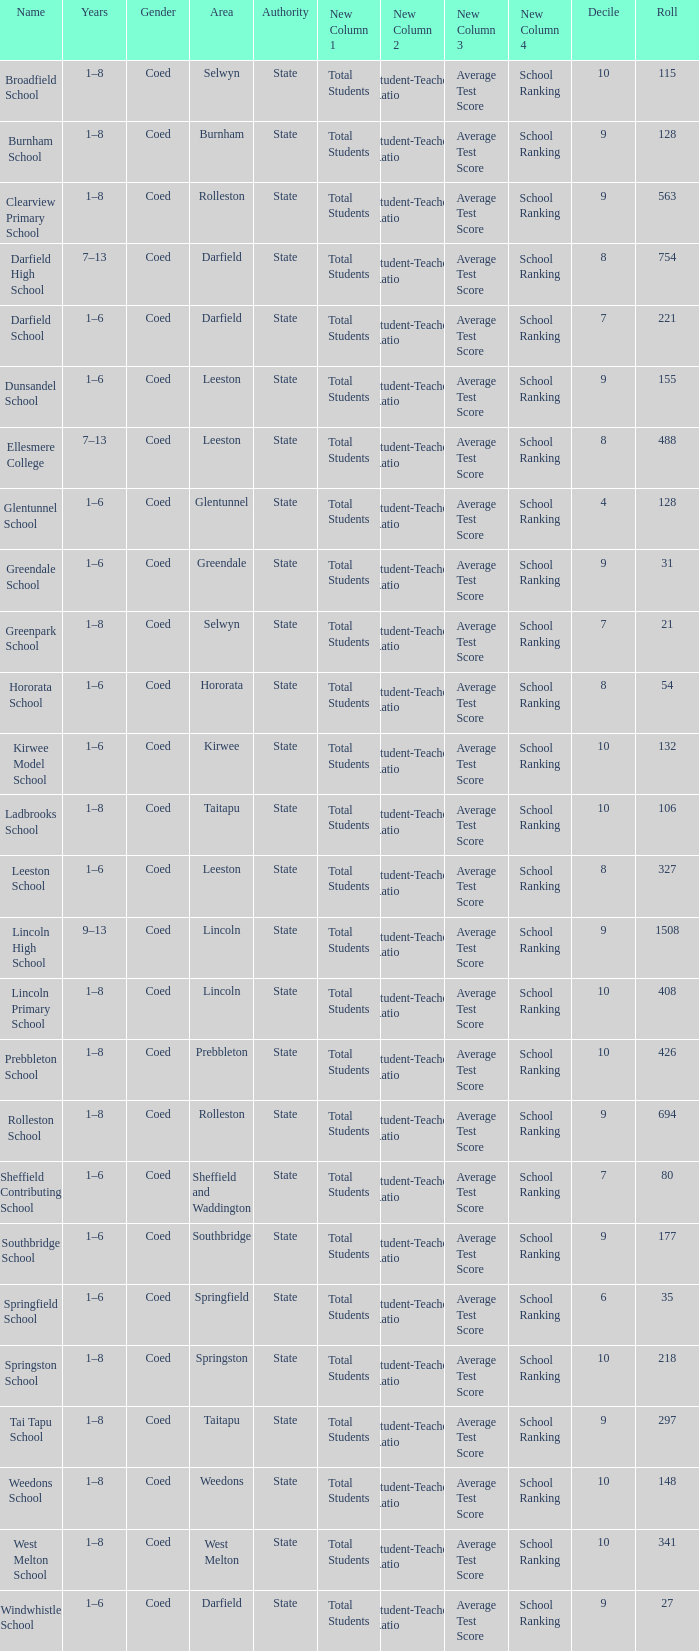Which name has a Roll larger than 297, and Years of 7–13? Darfield High School, Ellesmere College. Parse the table in full. {'header': ['Name', 'Years', 'Gender', 'Area', 'Authority', 'New Column 1', 'New Column 2', 'New Column 3', 'New Column 4', 'Decile', 'Roll'], 'rows': [['Broadfield School', '1–8', 'Coed', 'Selwyn', 'State', 'Total Students', 'Student-Teacher Ratio', 'Average Test Score', 'School Ranking', '10', '115'], ['Burnham School', '1–8', 'Coed', 'Burnham', 'State', 'Total Students', 'Student-Teacher Ratio', 'Average Test Score', 'School Ranking', '9', '128'], ['Clearview Primary School', '1–8', 'Coed', 'Rolleston', 'State', 'Total Students', 'Student-Teacher Ratio', 'Average Test Score', 'School Ranking', '9', '563'], ['Darfield High School', '7–13', 'Coed', 'Darfield', 'State', 'Total Students', 'Student-Teacher Ratio', 'Average Test Score', 'School Ranking', '8', '754'], ['Darfield School', '1–6', 'Coed', 'Darfield', 'State', 'Total Students', 'Student-Teacher Ratio', 'Average Test Score', 'School Ranking', '7', '221'], ['Dunsandel School', '1–6', 'Coed', 'Leeston', 'State', 'Total Students', 'Student-Teacher Ratio', 'Average Test Score', 'School Ranking', '9', '155'], ['Ellesmere College', '7–13', 'Coed', 'Leeston', 'State', 'Total Students', 'Student-Teacher Ratio', 'Average Test Score', 'School Ranking', '8', '488'], ['Glentunnel School', '1–6', 'Coed', 'Glentunnel', 'State', 'Total Students', 'Student-Teacher Ratio', 'Average Test Score', 'School Ranking', '4', '128'], ['Greendale School', '1–6', 'Coed', 'Greendale', 'State', 'Total Students', 'Student-Teacher Ratio', 'Average Test Score', 'School Ranking', '9', '31'], ['Greenpark School', '1–8', 'Coed', 'Selwyn', 'State', 'Total Students', 'Student-Teacher Ratio', 'Average Test Score', 'School Ranking', '7', '21'], ['Hororata School', '1–6', 'Coed', 'Hororata', 'State', 'Total Students', 'Student-Teacher Ratio', 'Average Test Score', 'School Ranking', '8', '54'], ['Kirwee Model School', '1–6', 'Coed', 'Kirwee', 'State', 'Total Students', 'Student-Teacher Ratio', 'Average Test Score', 'School Ranking', '10', '132'], ['Ladbrooks School', '1–8', 'Coed', 'Taitapu', 'State', 'Total Students', 'Student-Teacher Ratio', 'Average Test Score', 'School Ranking', '10', '106'], ['Leeston School', '1–6', 'Coed', 'Leeston', 'State', 'Total Students', 'Student-Teacher Ratio', 'Average Test Score', 'School Ranking', '8', '327'], ['Lincoln High School', '9–13', 'Coed', 'Lincoln', 'State', 'Total Students', 'Student-Teacher Ratio', 'Average Test Score', 'School Ranking', '9', '1508'], ['Lincoln Primary School', '1–8', 'Coed', 'Lincoln', 'State', 'Total Students', 'Student-Teacher Ratio', 'Average Test Score', 'School Ranking', '10', '408'], ['Prebbleton School', '1–8', 'Coed', 'Prebbleton', 'State', 'Total Students', 'Student-Teacher Ratio', 'Average Test Score', 'School Ranking', '10', '426'], ['Rolleston School', '1–8', 'Coed', 'Rolleston', 'State', 'Total Students', 'Student-Teacher Ratio', 'Average Test Score', 'School Ranking', '9', '694'], ['Sheffield Contributing School', '1–6', 'Coed', 'Sheffield and Waddington', 'State', 'Total Students', 'Student-Teacher Ratio', 'Average Test Score', 'School Ranking', '7', '80'], ['Southbridge School', '1–6', 'Coed', 'Southbridge', 'State', 'Total Students', 'Student-Teacher Ratio', 'Average Test Score', 'School Ranking', '9', '177'], ['Springfield School', '1–6', 'Coed', 'Springfield', 'State', 'Total Students', 'Student-Teacher Ratio', 'Average Test Score', 'School Ranking', '6', '35'], ['Springston School', '1–8', 'Coed', 'Springston', 'State', 'Total Students', 'Student-Teacher Ratio', 'Average Test Score', 'School Ranking', '10', '218'], ['Tai Tapu School', '1–8', 'Coed', 'Taitapu', 'State', 'Total Students', 'Student-Teacher Ratio', 'Average Test Score', 'School Ranking', '9', '297'], ['Weedons School', '1–8', 'Coed', 'Weedons', 'State', 'Total Students', 'Student-Teacher Ratio', 'Average Test Score', 'School Ranking', '10', '148'], ['West Melton School', '1–8', 'Coed', 'West Melton', 'State', 'Total Students', 'Student-Teacher Ratio', 'Average Test Score', 'School Ranking', '10', '341'], ['Windwhistle School', '1–6', 'Coed', 'Darfield', 'State', 'Total Students', 'Student-Teacher Ratio', 'Average Test Score', 'School Ranking', '9', '27']]} 